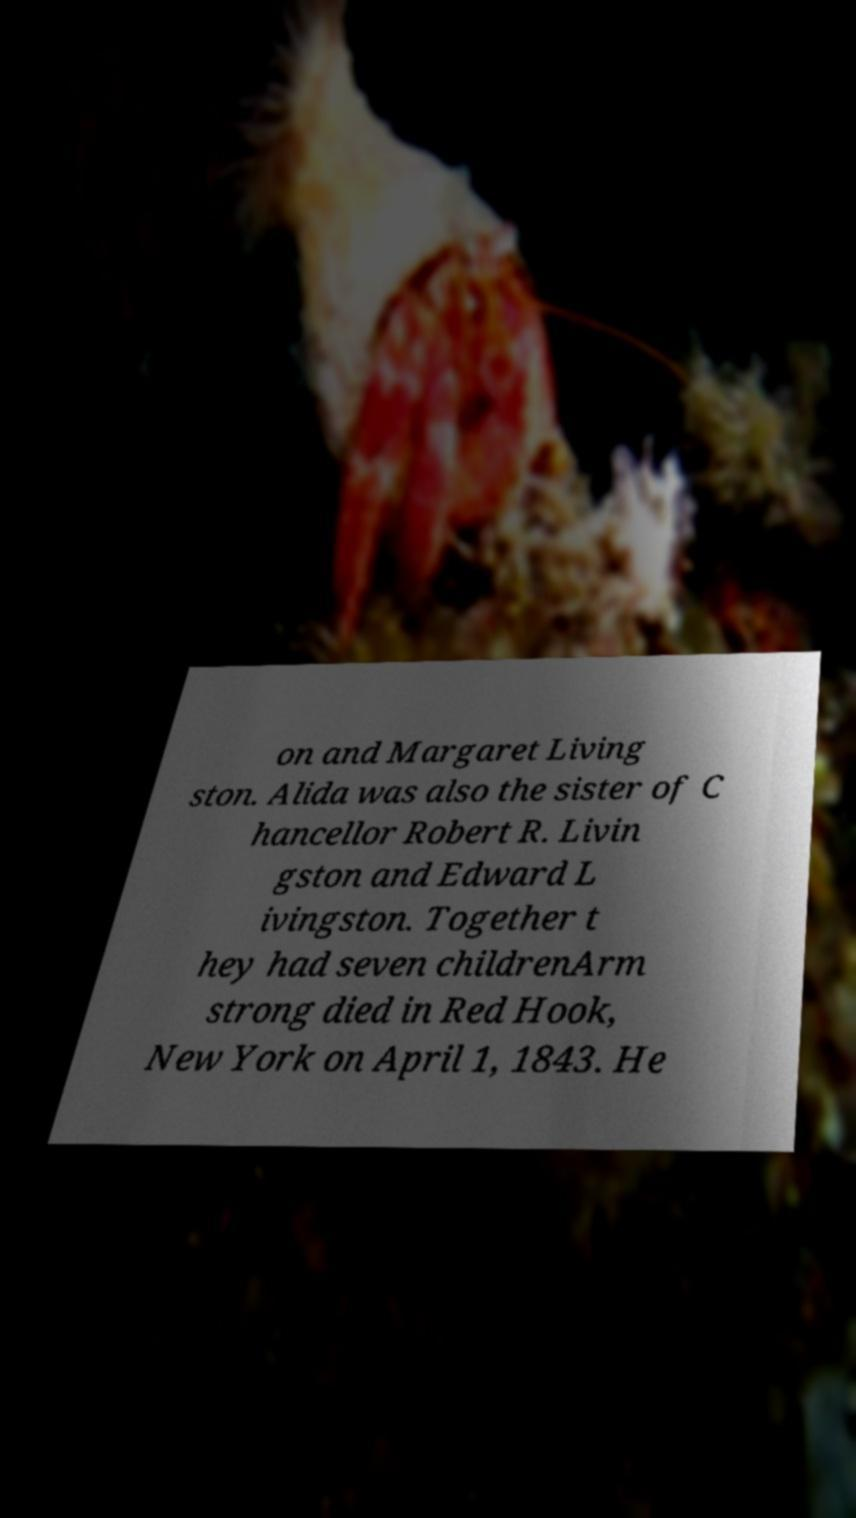Can you read and provide the text displayed in the image?This photo seems to have some interesting text. Can you extract and type it out for me? on and Margaret Living ston. Alida was also the sister of C hancellor Robert R. Livin gston and Edward L ivingston. Together t hey had seven childrenArm strong died in Red Hook, New York on April 1, 1843. He 